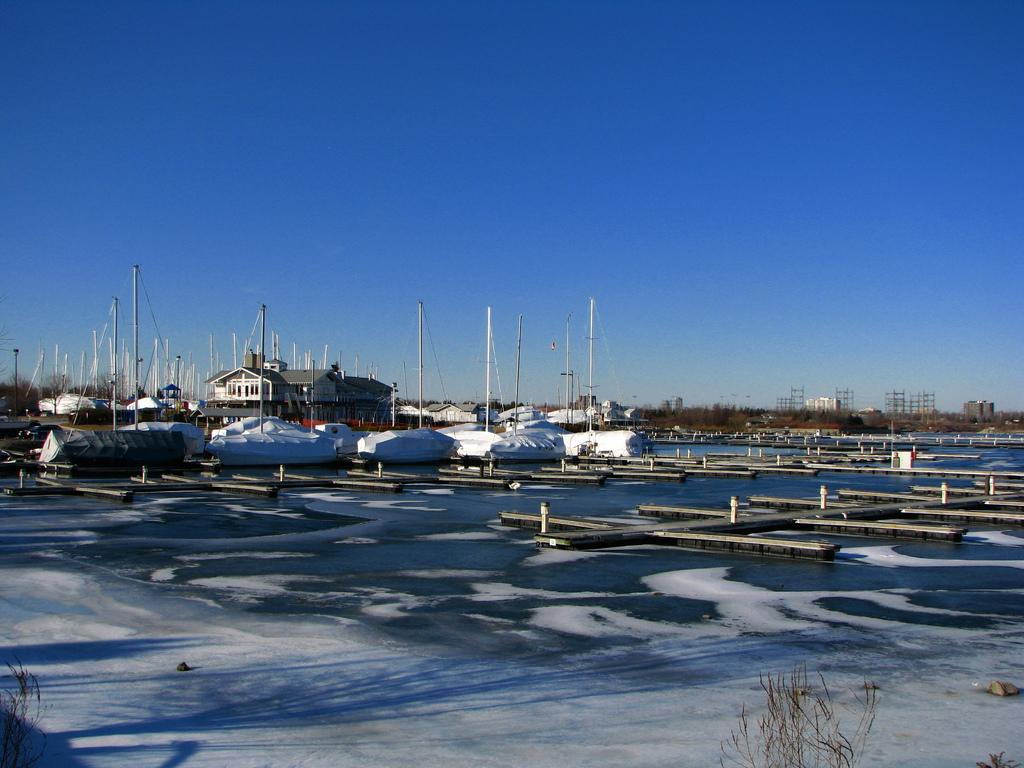What structure is located near the water in the image? There is a dock in the image. What other type of structure can be seen in the image? There is a building in the image. What objects are in the middle of the image? There are poles in the middle of the image. What is visible at the top of the image? The sky is visible at the top of the image. Where is the toy located in the image? There is no toy present in the image. What type of bedroom can be seen in the image? There is no bedroom present in the image. 